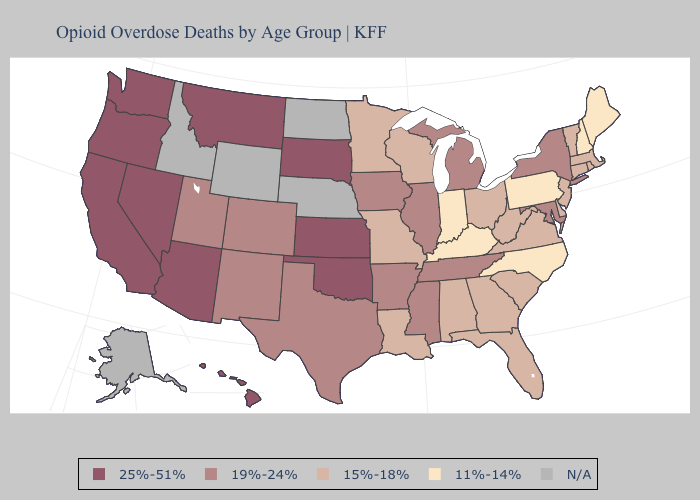Does the first symbol in the legend represent the smallest category?
Give a very brief answer. No. Does the map have missing data?
Quick response, please. Yes. Name the states that have a value in the range N/A?
Keep it brief. Alaska, Idaho, Nebraska, North Dakota, Wyoming. Name the states that have a value in the range 19%-24%?
Write a very short answer. Arkansas, Colorado, Illinois, Iowa, Maryland, Michigan, Mississippi, New Mexico, New York, Tennessee, Texas, Utah. What is the highest value in the USA?
Answer briefly. 25%-51%. Among the states that border Arizona , which have the highest value?
Short answer required. California, Nevada. Name the states that have a value in the range 19%-24%?
Keep it brief. Arkansas, Colorado, Illinois, Iowa, Maryland, Michigan, Mississippi, New Mexico, New York, Tennessee, Texas, Utah. Name the states that have a value in the range 19%-24%?
Give a very brief answer. Arkansas, Colorado, Illinois, Iowa, Maryland, Michigan, Mississippi, New Mexico, New York, Tennessee, Texas, Utah. Among the states that border Kansas , does Missouri have the lowest value?
Answer briefly. Yes. What is the value of Idaho?
Be succinct. N/A. Does the first symbol in the legend represent the smallest category?
Be succinct. No. Does the first symbol in the legend represent the smallest category?
Quick response, please. No. Among the states that border Nevada , which have the lowest value?
Answer briefly. Utah. Which states have the highest value in the USA?
Keep it brief. Arizona, California, Hawaii, Kansas, Montana, Nevada, Oklahoma, Oregon, South Dakota, Washington. 